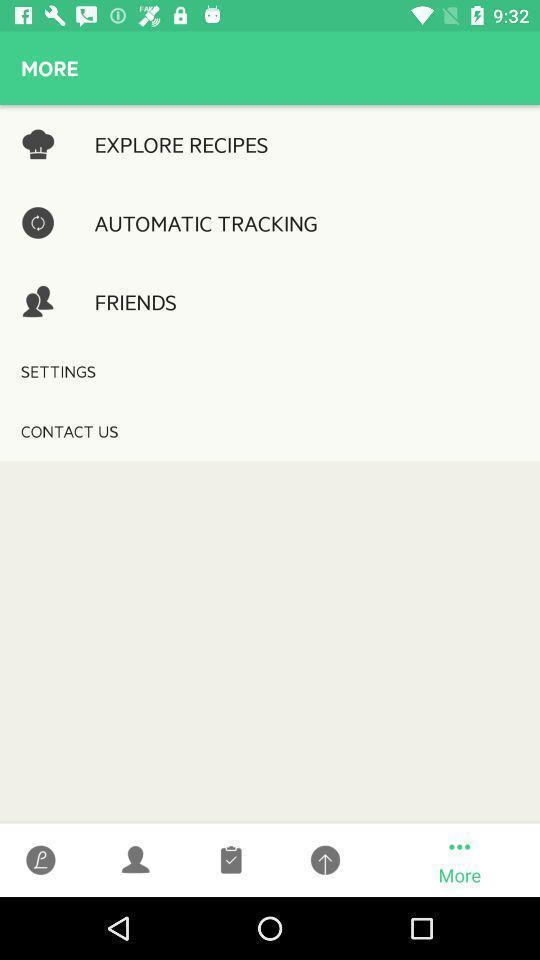Summarize the main components in this picture. Page displaying the list of different options. 